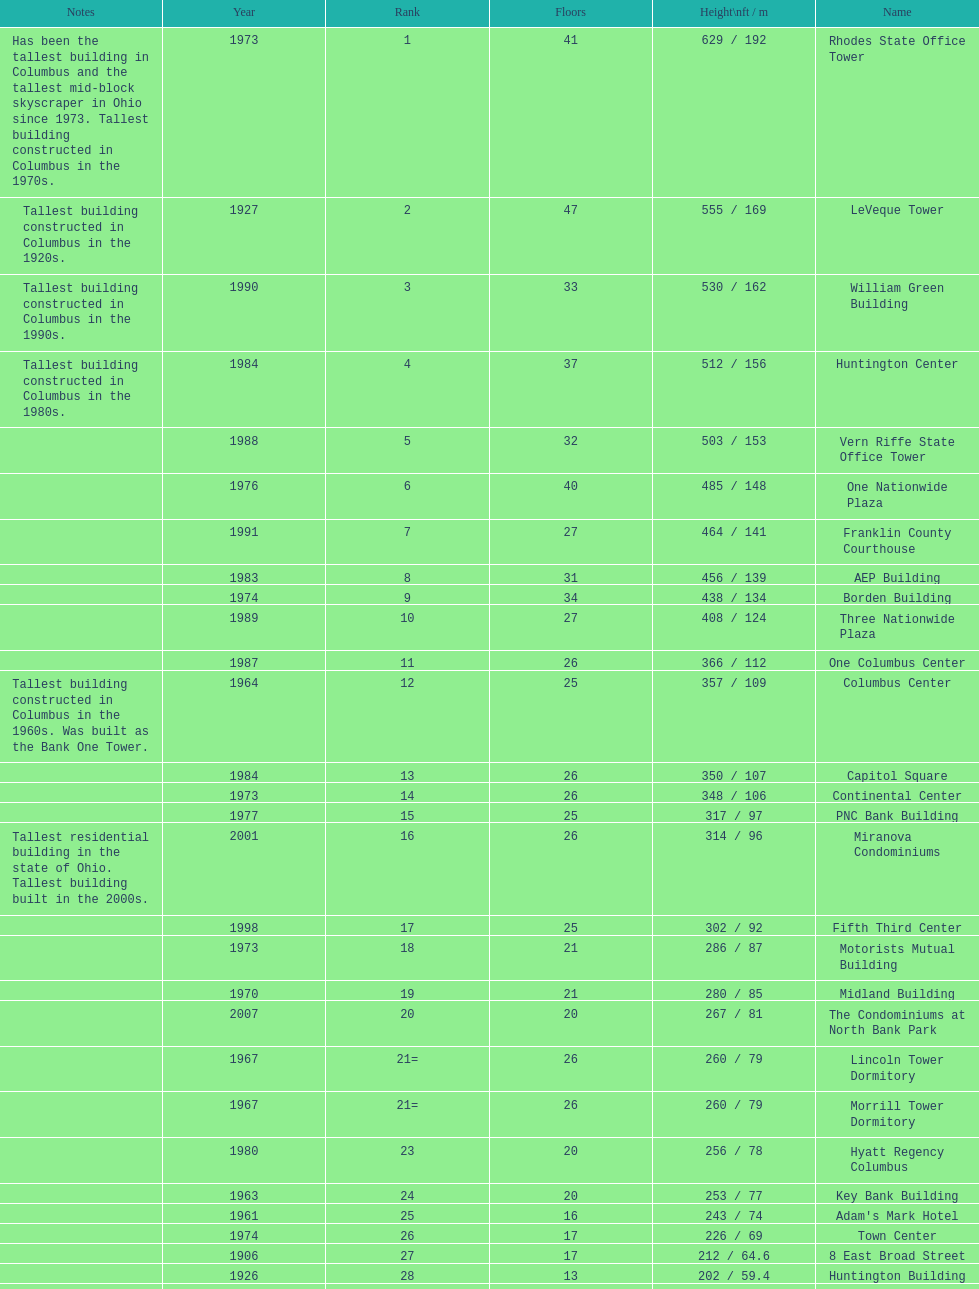Which is the tallest building? Rhodes State Office Tower. 